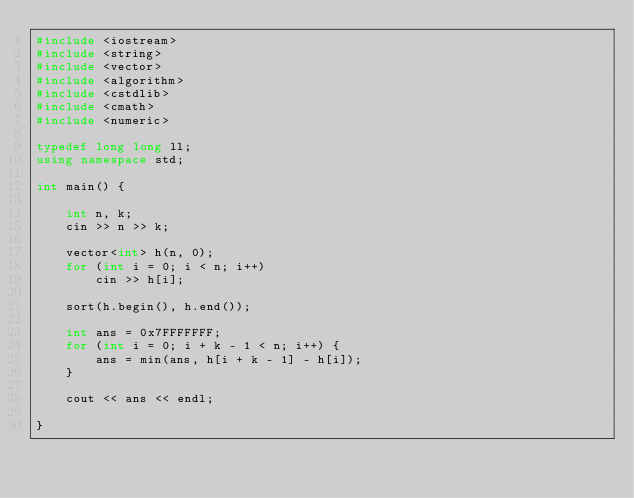Convert code to text. <code><loc_0><loc_0><loc_500><loc_500><_C++_>#include <iostream>
#include <string>
#include <vector>
#include <algorithm>
#include <cstdlib>
#include <cmath>
#include <numeric>

typedef long long ll;
using namespace std;

int main() {
    
    int n, k;
    cin >> n >> k;
    
    vector<int> h(n, 0);
    for (int i = 0; i < n; i++)
        cin >> h[i];
    
    sort(h.begin(), h.end());
    
    int ans = 0x7FFFFFFF;
    for (int i = 0; i + k - 1 < n; i++) {
        ans = min(ans, h[i + k - 1] - h[i]);
    }
    
    cout << ans << endl;
    
}</code> 